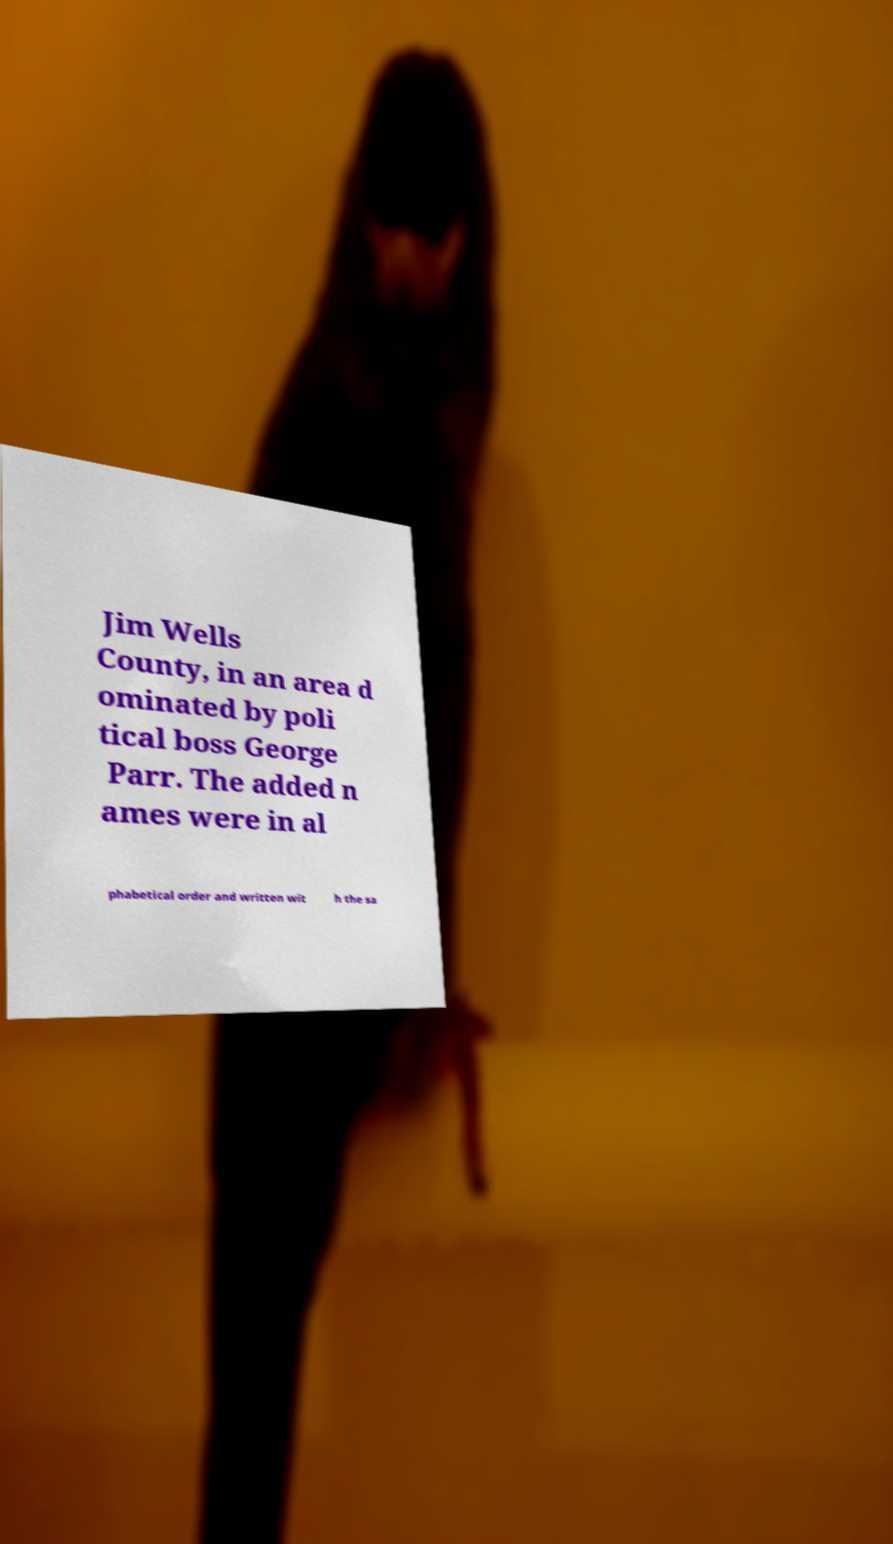There's text embedded in this image that I need extracted. Can you transcribe it verbatim? Jim Wells County, in an area d ominated by poli tical boss George Parr. The added n ames were in al phabetical order and written wit h the sa 